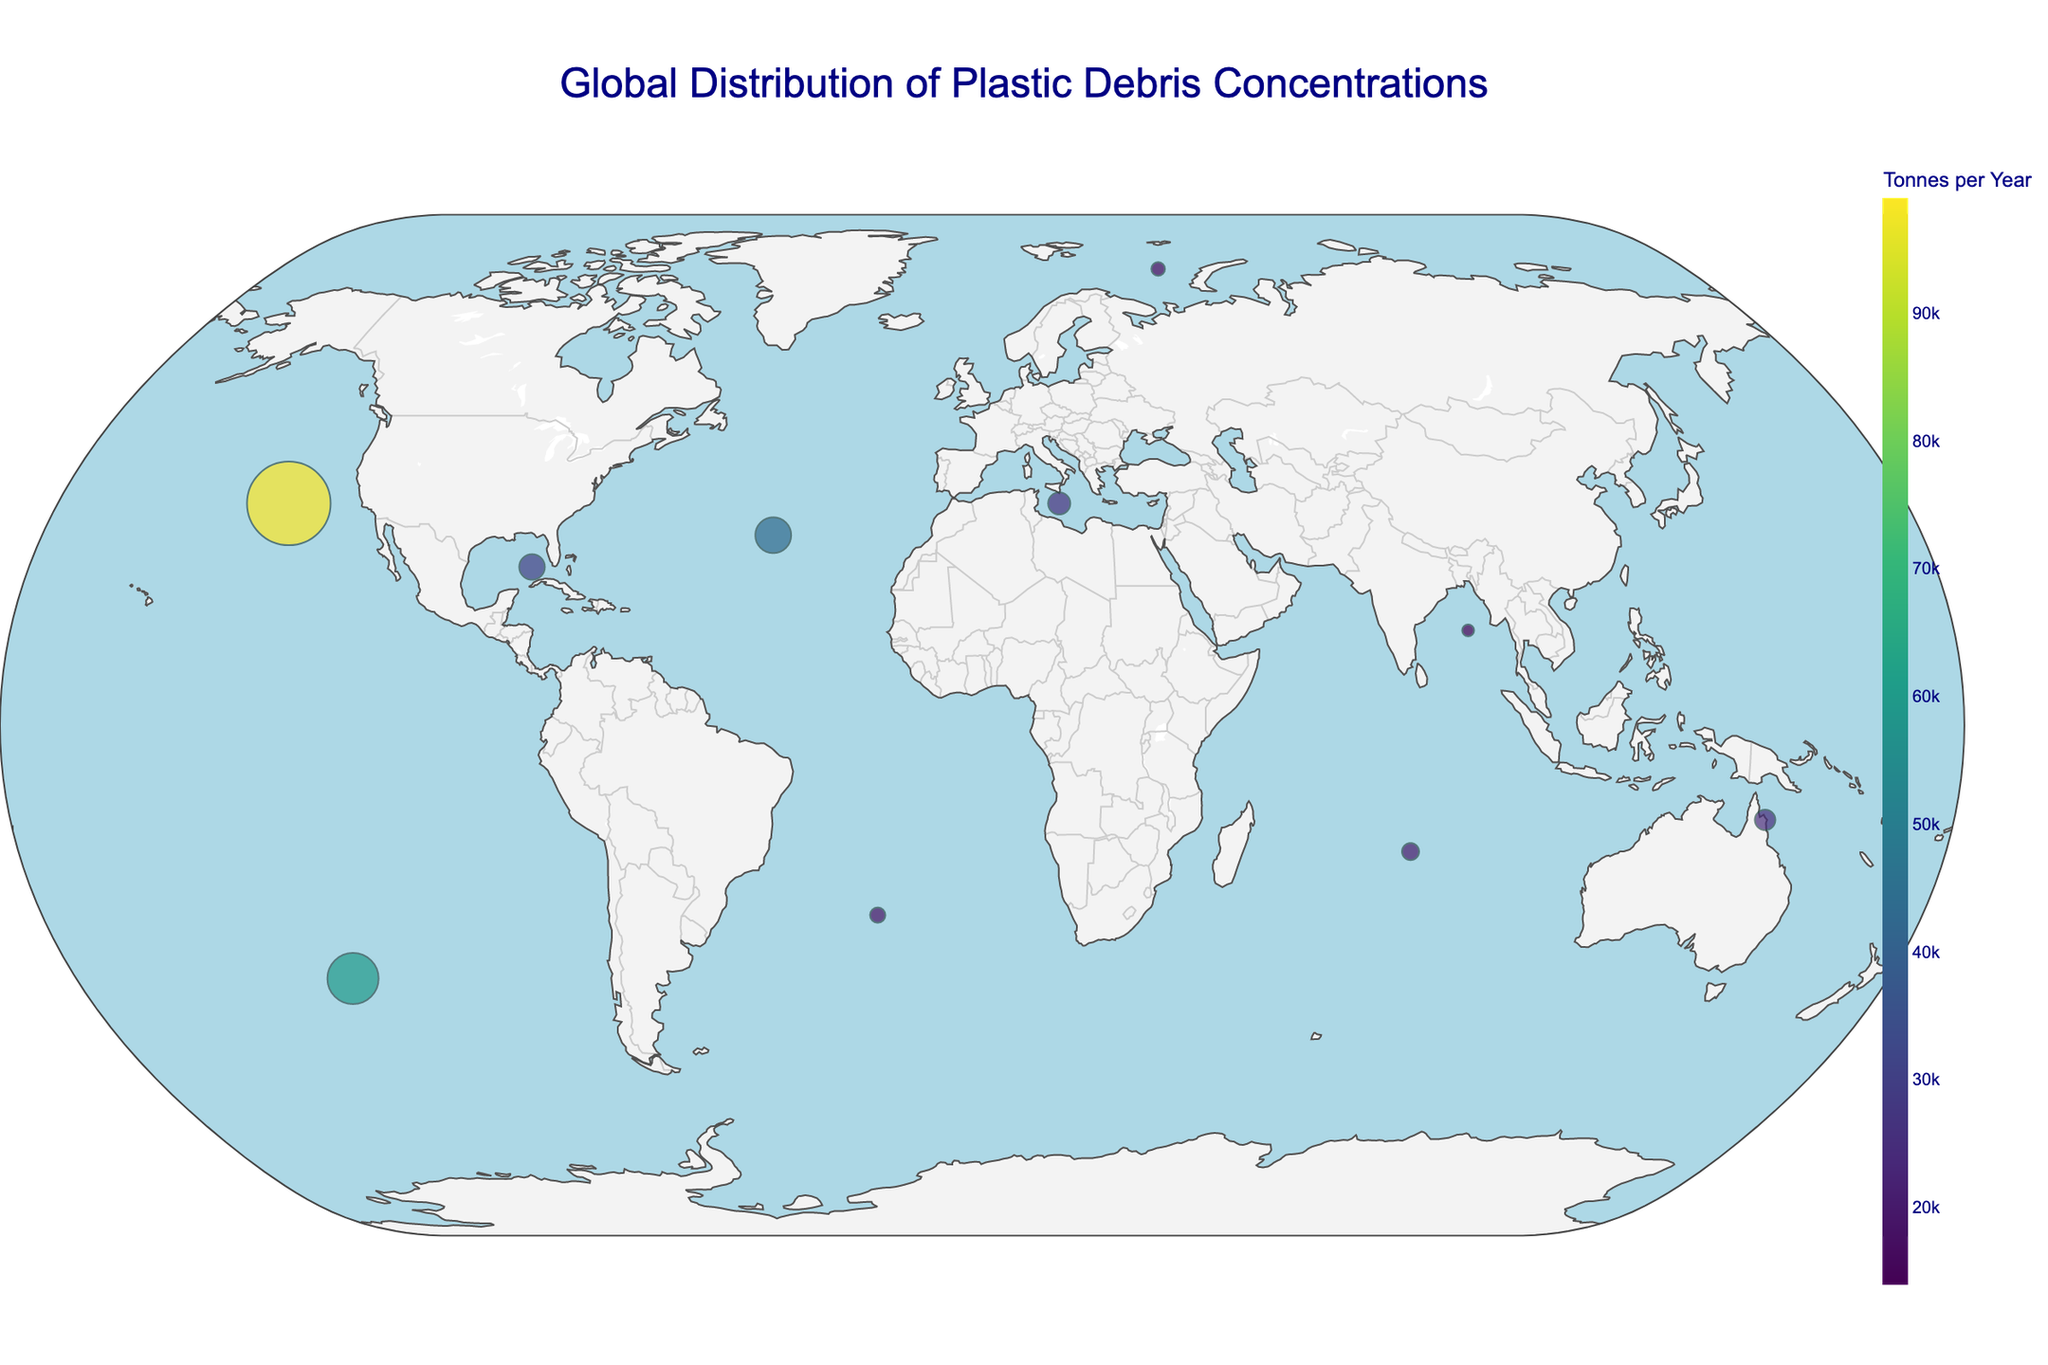what is the title of the figure? The title of the figure is prominently displayed at the top center of the plot. It gives a clear understanding of what the figure represents.
Answer: Global Distribution of Plastic Debris Concentrations How many regions have plastic concentrations higher than 1 million pieces? By counting the number of bubbles with sizes indicating plastic concentrations higher than 1 million pieces, we find those regions.
Answer: 6 Which region has the highest plastic concentration? The size of the bubble represents the plastic concentration, and the largest bubble on the figure indicates the highest plastic concentration. The North Pacific Gyre has the largest bubble.
Answer: North Pacific Gyre What is the plastic concentration in the Gulf of Mexico? Hovering over the bubble located in the Gulf of Mexico region provides the specific plastic concentration in that area.
Answer: 1,500,000 pieces Compare the plastic concentration of the North Pacific Gyre and the Indian Ocean Gyre. Which one is higher and by how much? The North Pacific Gyre has a plastic concentration of 4,900,000 pieces, and the Indian Ocean Gyre has 1,000,000 pieces. Subtracting these values gives the difference.
Answer: North Pacific Gyre is higher by 3,900,000 pieces Which ocean current is associated with the Mediterranean Sea? The annotation text near the Mediterranean Sea region provides the name of the ocean current.
Answer: Levantine Intermediate Water Which region has the lowest tonnes per year of plastic debris? By observing the color scale and finding the bubble with the lightest color (indicating the lowest value), we can identify the region with the lowest tonnes per year.
Answer: Arctic Ocean What is the combined total of tonnes per year for the North Atlantic Gyre and the South Pacific Gyre? Adding the tonnes per year values for both the North Atlantic Gyre (43,000 tonnes) and the South Pacific Gyre (60,000 tonnes) gives the total.
Answer: 103,000 tonnes Which regions are found in both the Northern and Southern Hemispheres? Reviewing the latitude values and finding regions with positive values (Northern Hemisphere) and negative values (Southern Hemisphere) identifies the regions.
Answer: None Does the size of a bubble correlate with its color intensity on the plot? Comparing the sizes of the bubbles with their respective color intensities (darker color represents higher tonnes per year), we can see if there is a correlation. Additionally, by noting the largest bubble (North Pacific Gyre) and its high tonnes per year color, we see a correlation.
Answer: Yes 